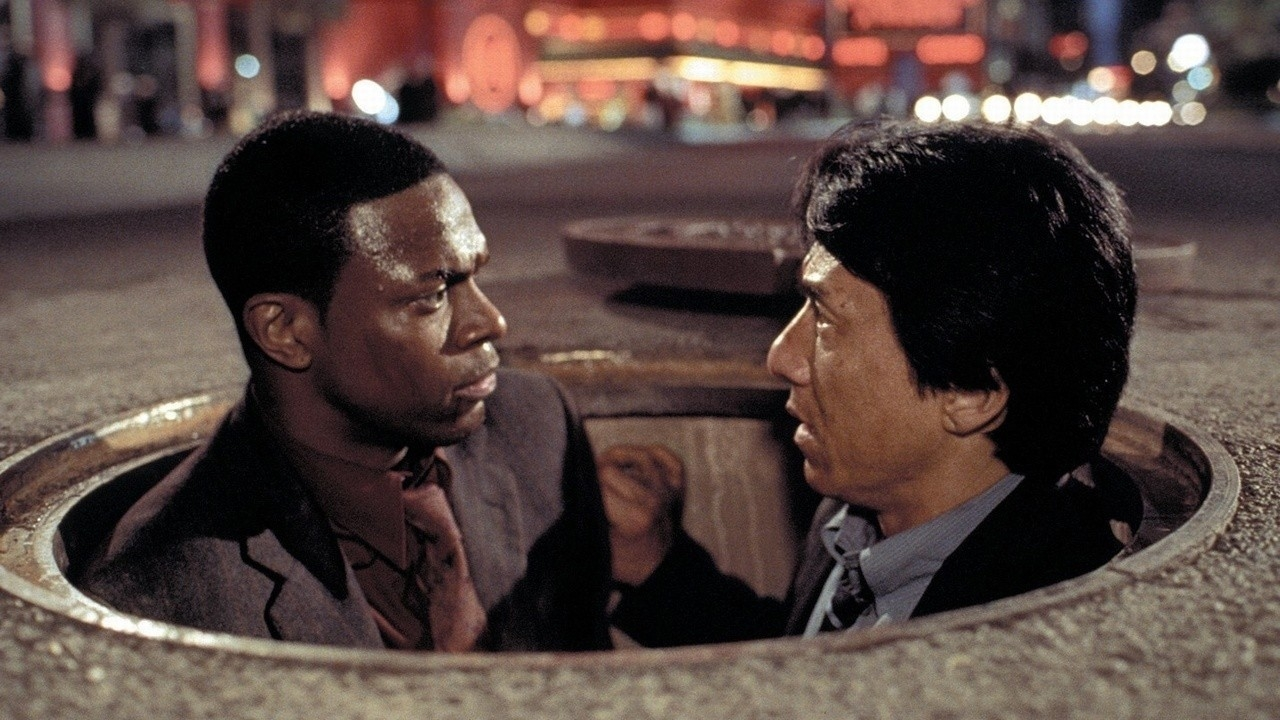Imagine you're writing a plot twist involving this manhole scene. What happens next? In a surprising plot twist, as the characters huddle in the manhole, the ground begins to shake. Suddenly, the manhole cover closes from above, trapping them inside. To their astonishment, the floor underneath them starts to move downwards, revealing a hidden underground facility that serves as the secret headquarters of their adversaries. As they descend into this unknown realm, they must quickly adapt to the new challenges and obstacles that await them, pushing their wits and skills to the limit. 